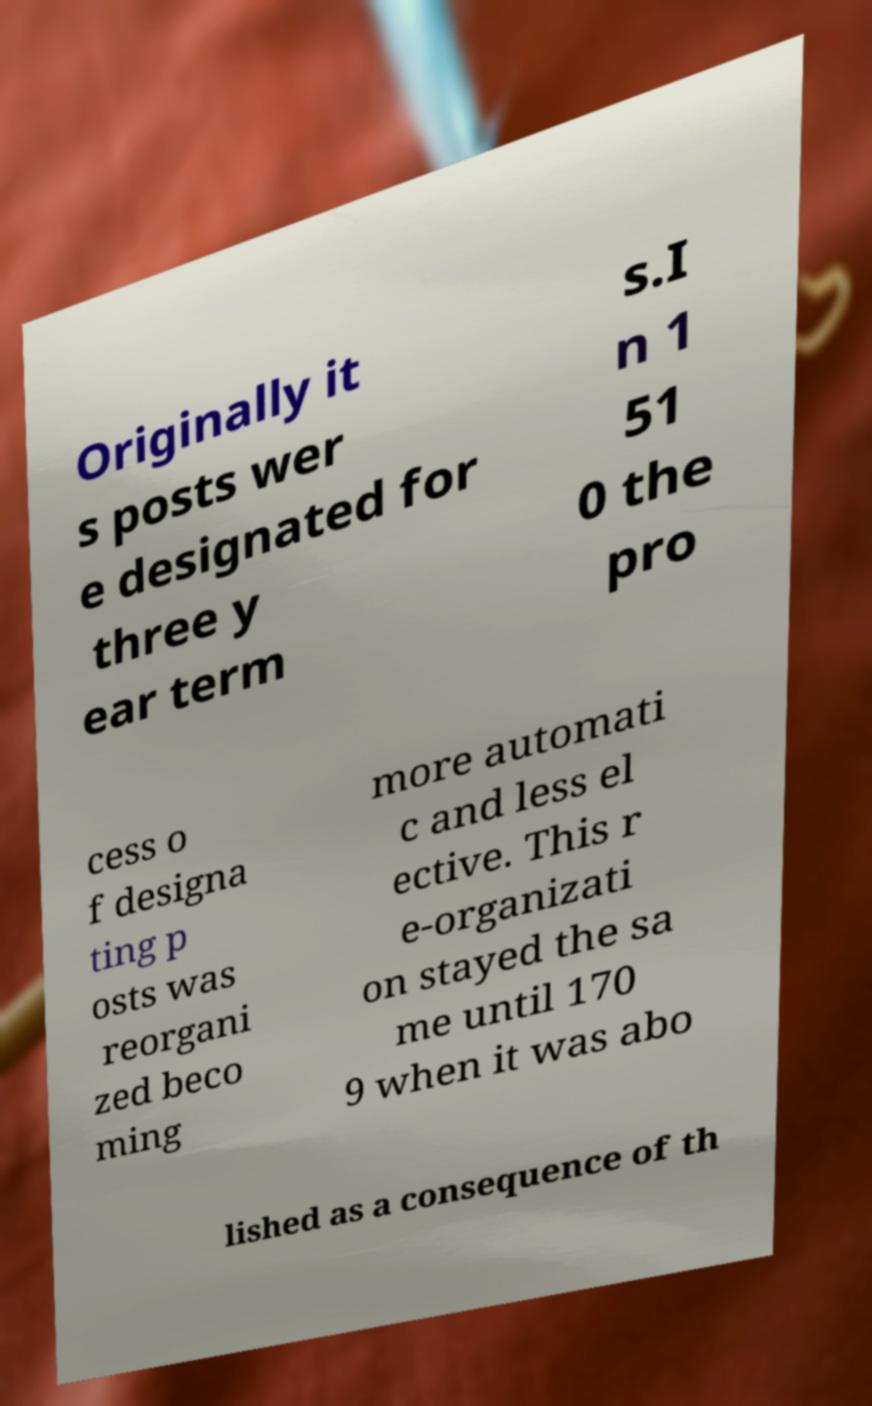For documentation purposes, I need the text within this image transcribed. Could you provide that? Originally it s posts wer e designated for three y ear term s.I n 1 51 0 the pro cess o f designa ting p osts was reorgani zed beco ming more automati c and less el ective. This r e-organizati on stayed the sa me until 170 9 when it was abo lished as a consequence of th 